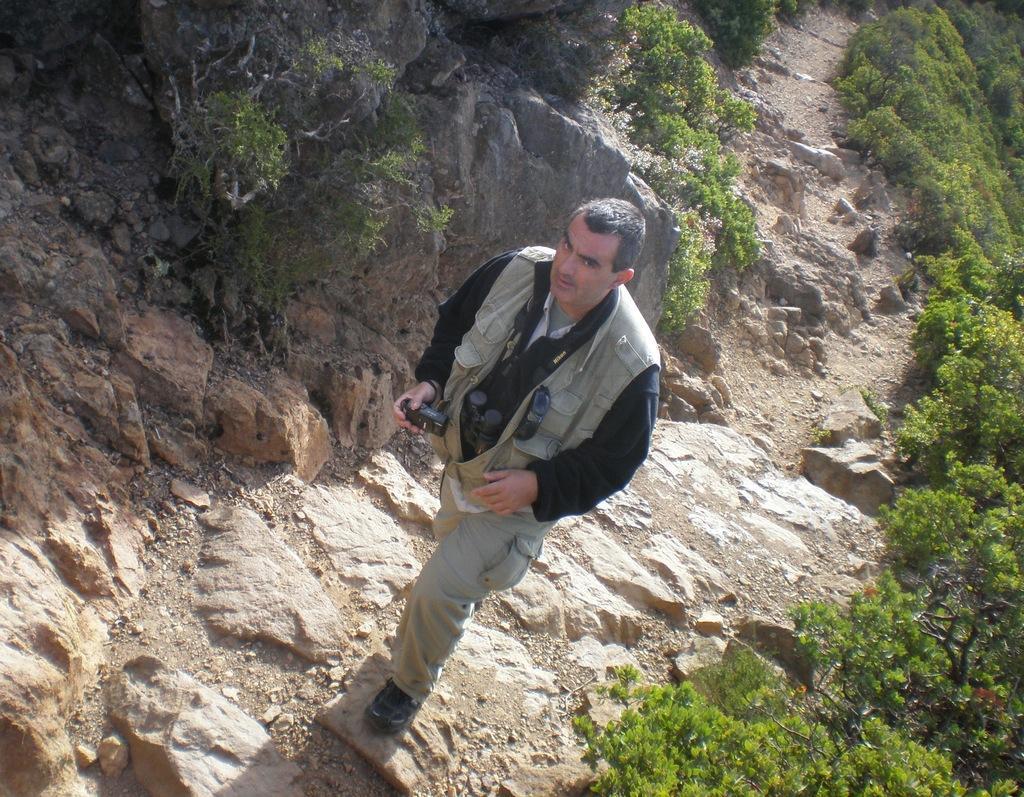How would you summarize this image in a sentence or two? In this image we can see a person. A man is holding a camera in the image. There are many plants and rocks in the image. 